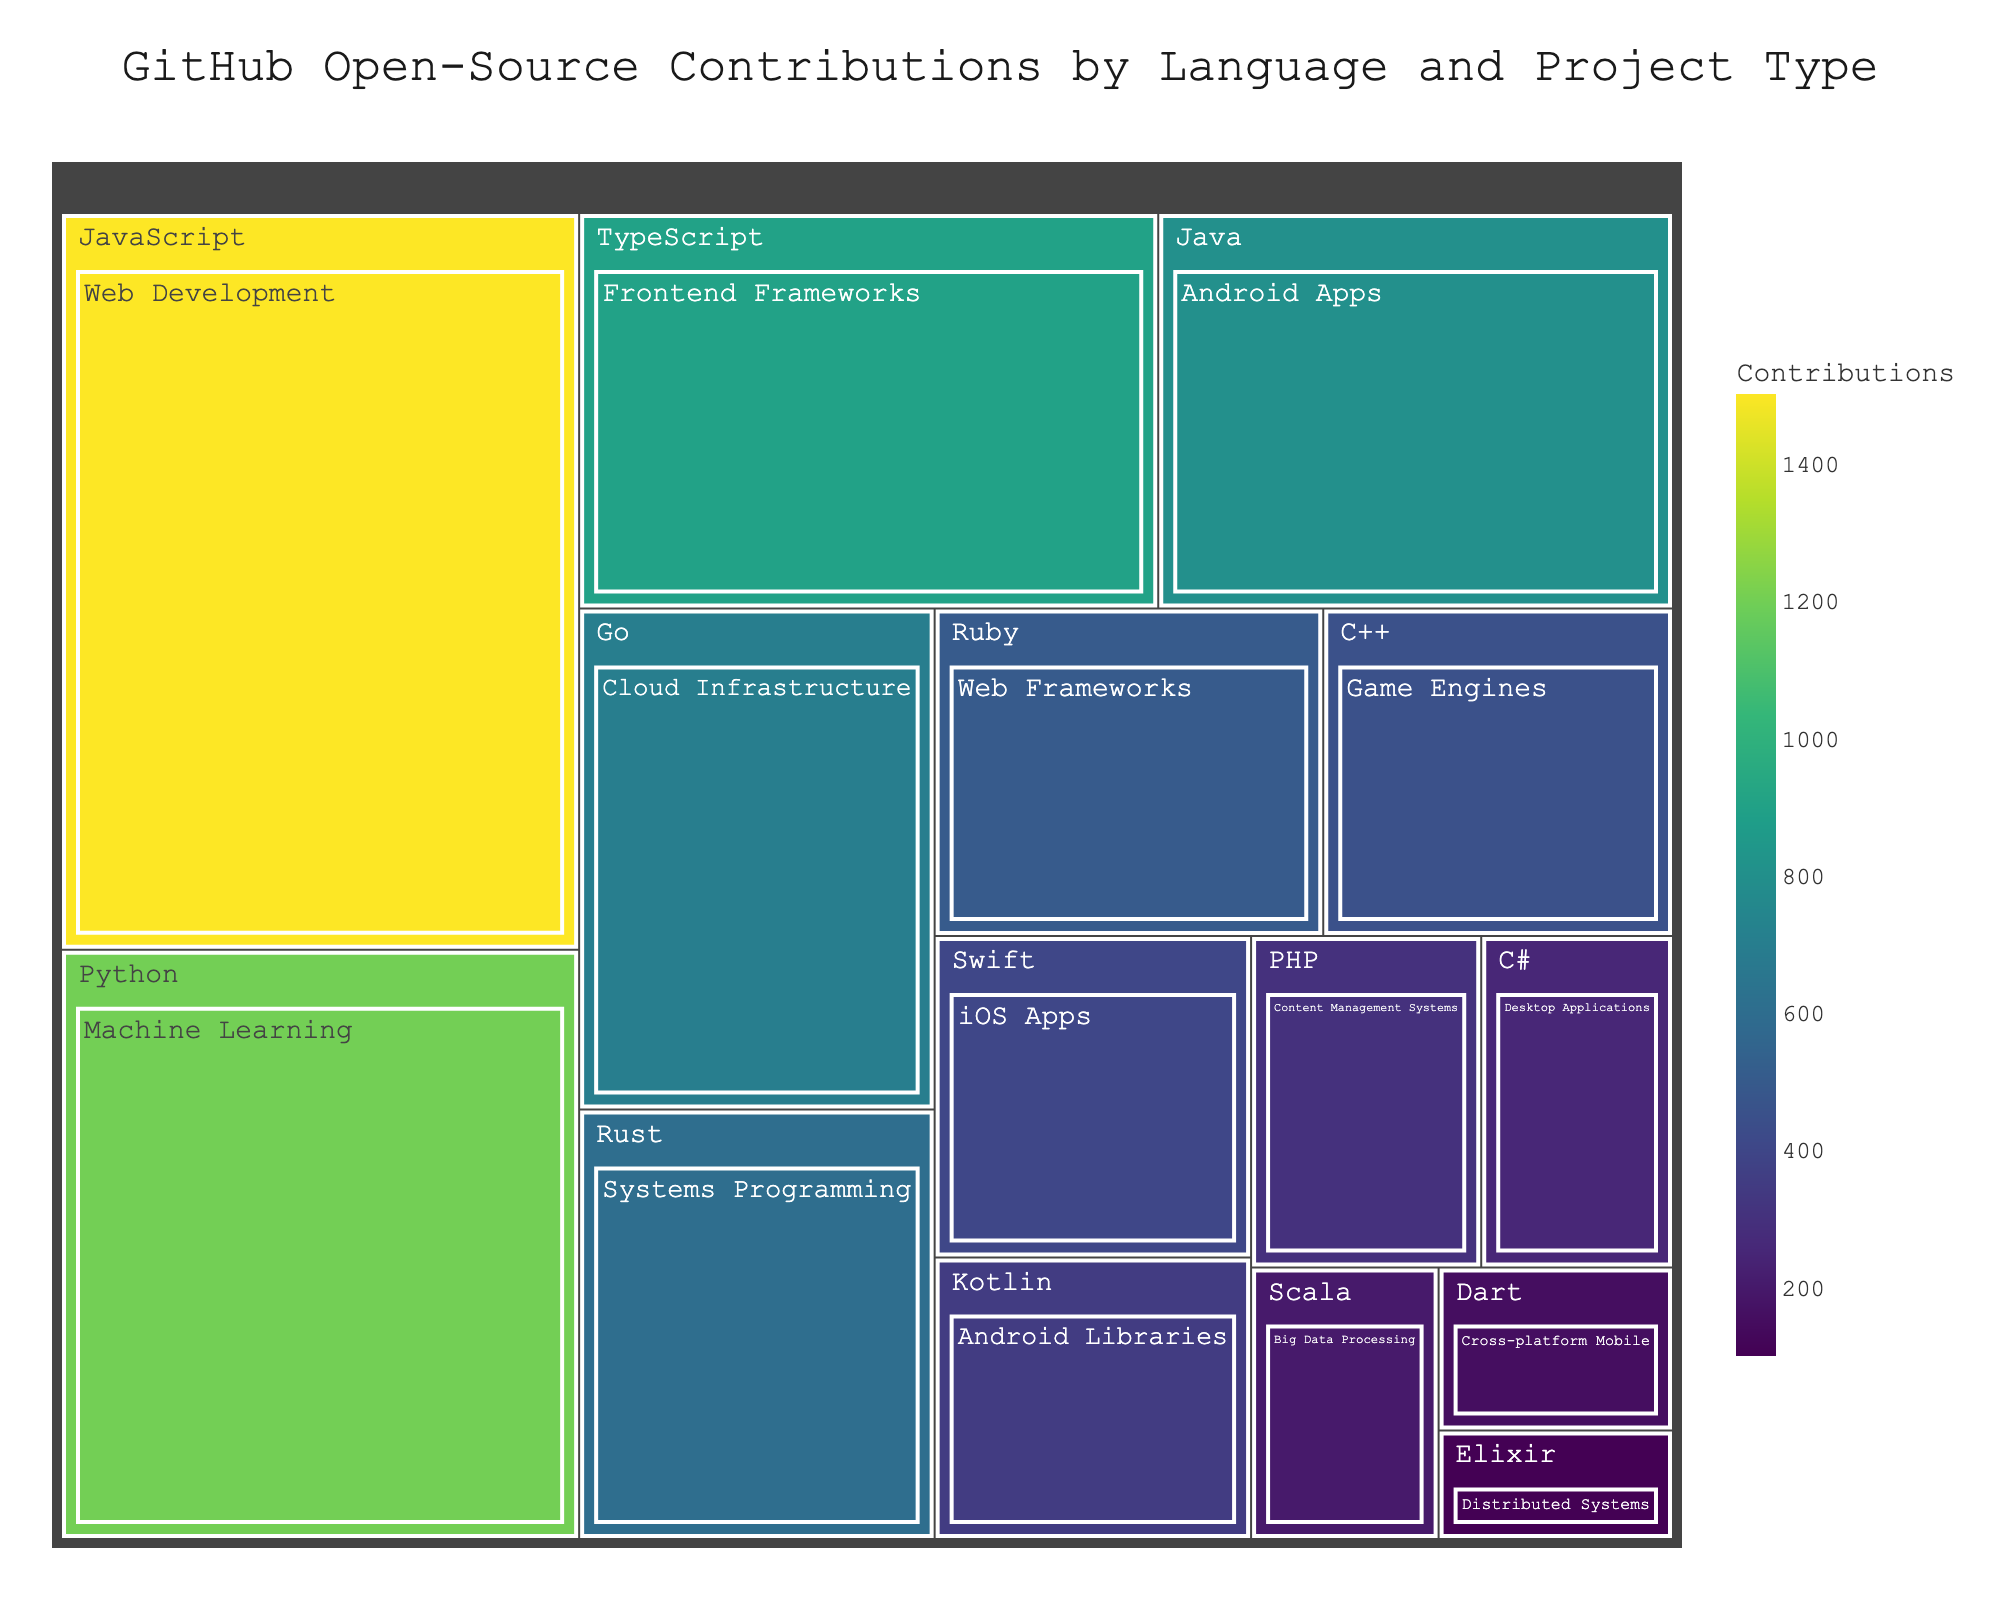what is the title of the treemap? The title is usually displayed at the top of the treemap in a larger and bold font.
Answer: GitHub Open-Source Contributions by Language and Project Type Which language has the highest contributions? To find the language with the highest contributions, locate the largest rectangle in the treemap.
Answer: JavaScript What project type is associated with the second highest number of contributions? The second largest rectangle in the treemap should indicate the project type with the second highest contributions.
Answer: Machine Learning How many contributions are made to cloud infrastructure projects? Locate the section of the treemap labeled "Cloud Infrastructure" and identify the contributions value.
Answer: 700 Compare contributions between web development and frontend frameworks. Which has more and by how much? Find the contributions for both web development (JavaScript) and frontend frameworks (TypeScript) and subtract the smaller from the larger. Web Development: 1500, Frontend Frameworks: 900, Difference: 1500-900=600
Answer: Web Development by 600 Calculate the total contributions for mobile-related projects (both Android and iOS). Sum the contributions for Android Apps, Android Libraries, and iOS Apps. Android Apps: 800, Android Libraries: 350, iOS Apps: 400, Total: 800+350+400=1550
Answer: 1550 Which language is associated with game engines, and how many contributions does it have? Look for the section labeled "Game Engines" and find the corresponding language and contributions number.
Answer: C++, 450 Which language has the fewest contributions, and what is the project type? Identify the smallest rectangle in the treemap to find the language and its associated project type with the fewest contributions.
Answer: Elixir, Distributed Systems What is the contribution difference between machine learning and systems programming? Subtract the contributions for systems programming (Rust) from the contributions for machine learning (Python). Machine Learning: 1200, Systems Programming: 600, Difference: 1200-600=600
Answer: 600 What is the combined contribution of big data processing and distributed systems projects? Sum the contributions for big data processing (Scala) and distributed systems (Elixir). Big Data Processing: 200, Distributed Systems: 100, Total: 200+100=300
Answer: 300 